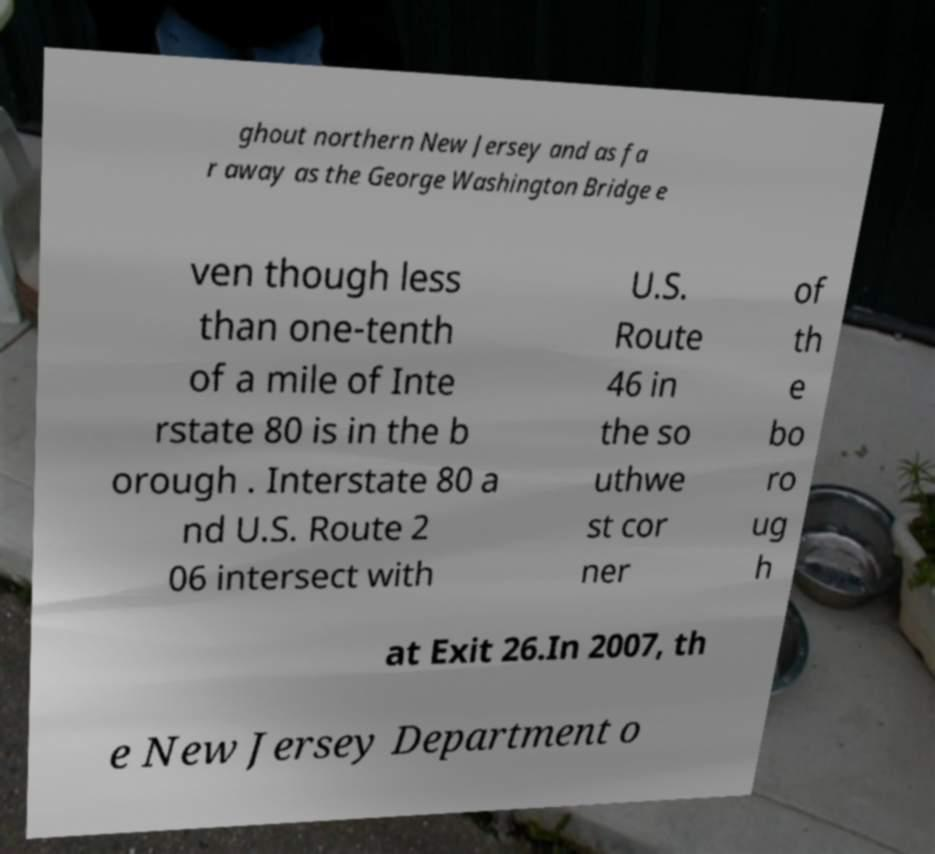Could you assist in decoding the text presented in this image and type it out clearly? ghout northern New Jersey and as fa r away as the George Washington Bridge e ven though less than one-tenth of a mile of Inte rstate 80 is in the b orough . Interstate 80 a nd U.S. Route 2 06 intersect with U.S. Route 46 in the so uthwe st cor ner of th e bo ro ug h at Exit 26.In 2007, th e New Jersey Department o 